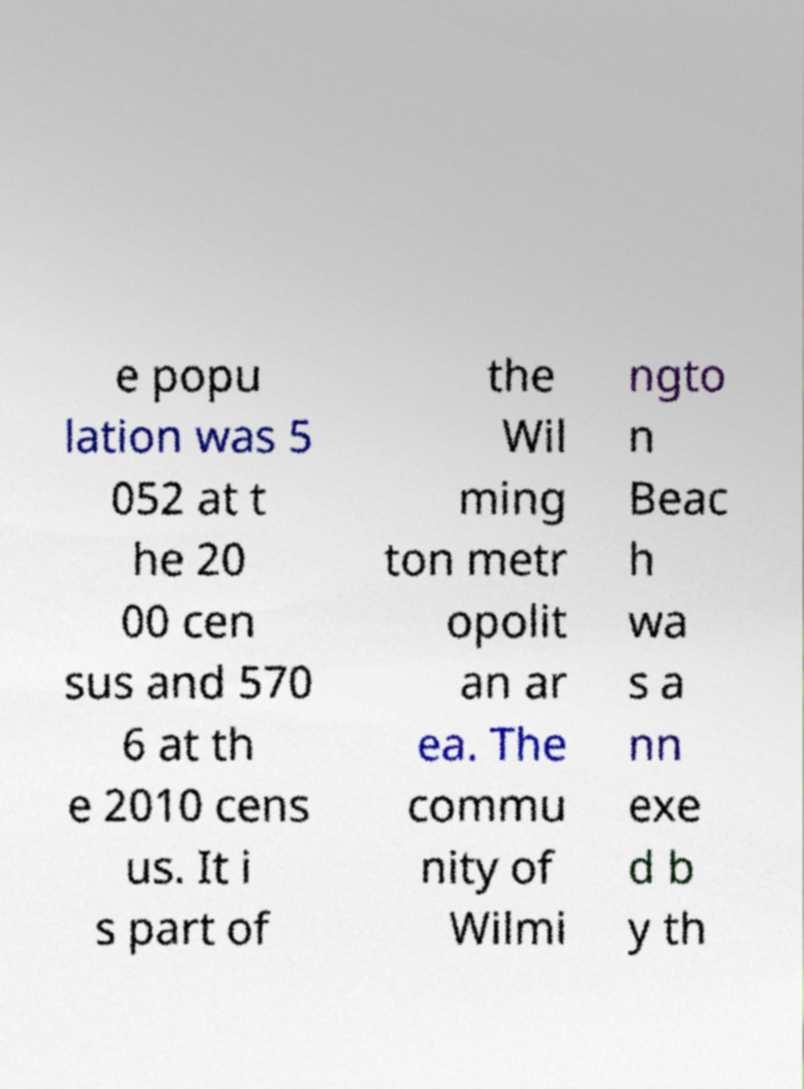There's text embedded in this image that I need extracted. Can you transcribe it verbatim? e popu lation was 5 052 at t he 20 00 cen sus and 570 6 at th e 2010 cens us. It i s part of the Wil ming ton metr opolit an ar ea. The commu nity of Wilmi ngto n Beac h wa s a nn exe d b y th 